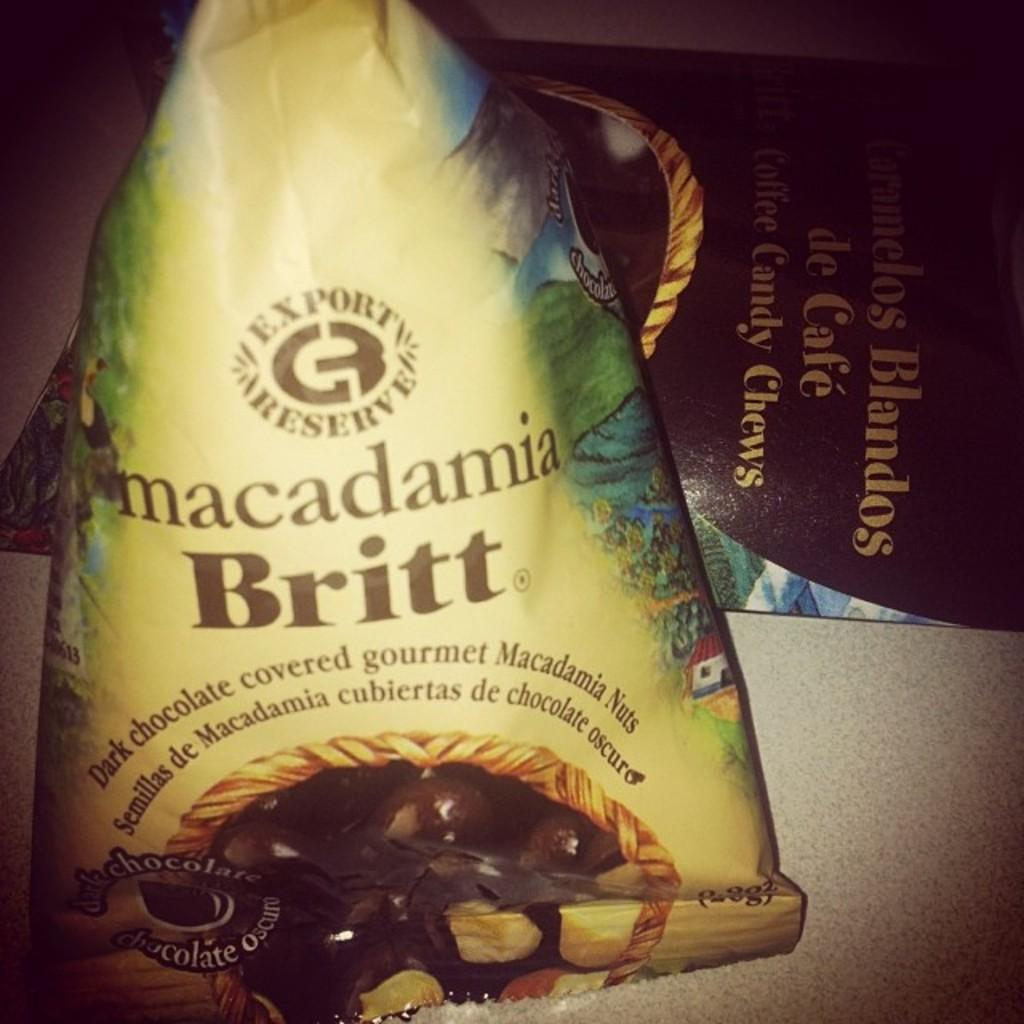<image>
Write a terse but informative summary of the picture. A package of dark chocolate macadamia nuts by Brit showing the chocolate covered nuts on the package. 